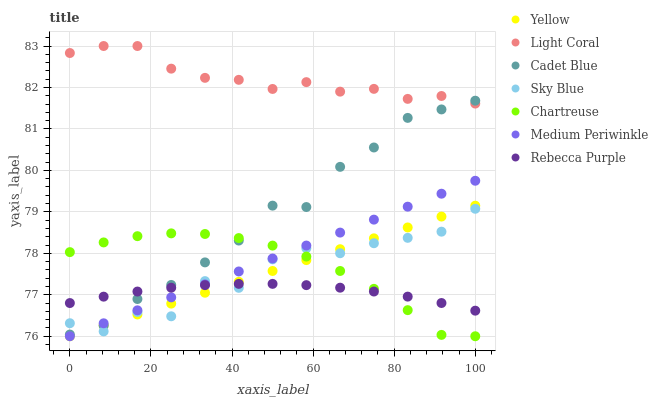Does Rebecca Purple have the minimum area under the curve?
Answer yes or no. Yes. Does Light Coral have the maximum area under the curve?
Answer yes or no. Yes. Does Medium Periwinkle have the minimum area under the curve?
Answer yes or no. No. Does Medium Periwinkle have the maximum area under the curve?
Answer yes or no. No. Is Yellow the smoothest?
Answer yes or no. Yes. Is Sky Blue the roughest?
Answer yes or no. Yes. Is Medium Periwinkle the smoothest?
Answer yes or no. No. Is Medium Periwinkle the roughest?
Answer yes or no. No. Does Medium Periwinkle have the lowest value?
Answer yes or no. Yes. Does Light Coral have the lowest value?
Answer yes or no. No. Does Light Coral have the highest value?
Answer yes or no. Yes. Does Medium Periwinkle have the highest value?
Answer yes or no. No. Is Yellow less than Light Coral?
Answer yes or no. Yes. Is Light Coral greater than Sky Blue?
Answer yes or no. Yes. Does Yellow intersect Rebecca Purple?
Answer yes or no. Yes. Is Yellow less than Rebecca Purple?
Answer yes or no. No. Is Yellow greater than Rebecca Purple?
Answer yes or no. No. Does Yellow intersect Light Coral?
Answer yes or no. No. 